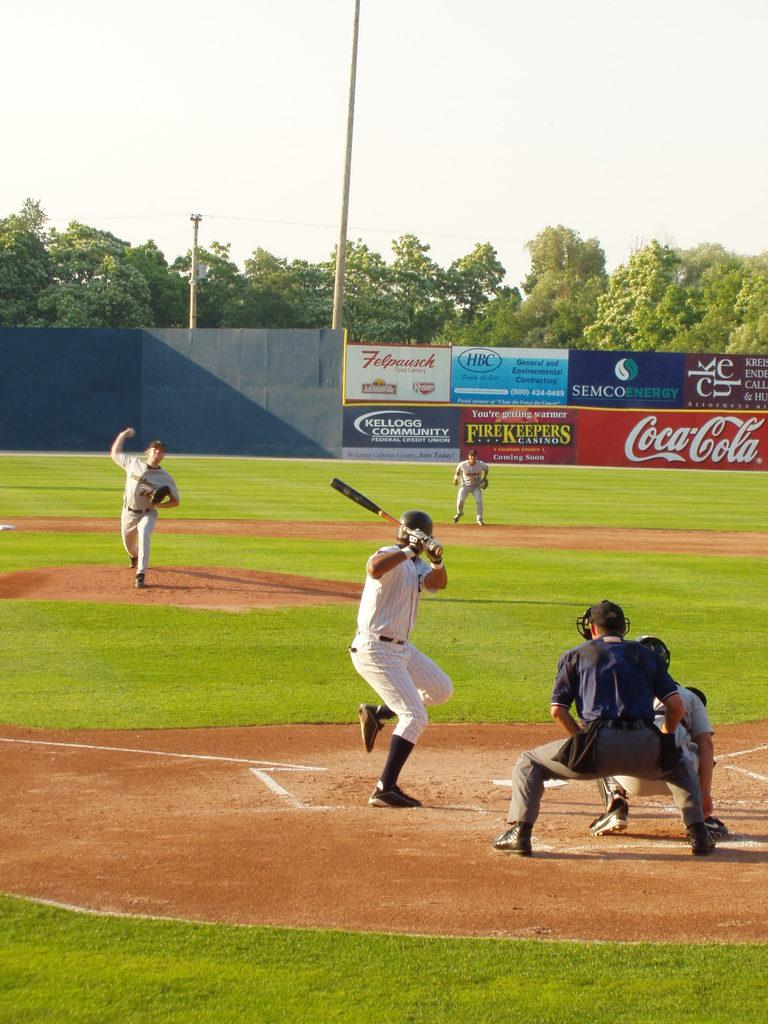<image>
Write a terse but informative summary of the picture. A baseball game taking place in a baseball field that is sponsored by Coca Cola. 